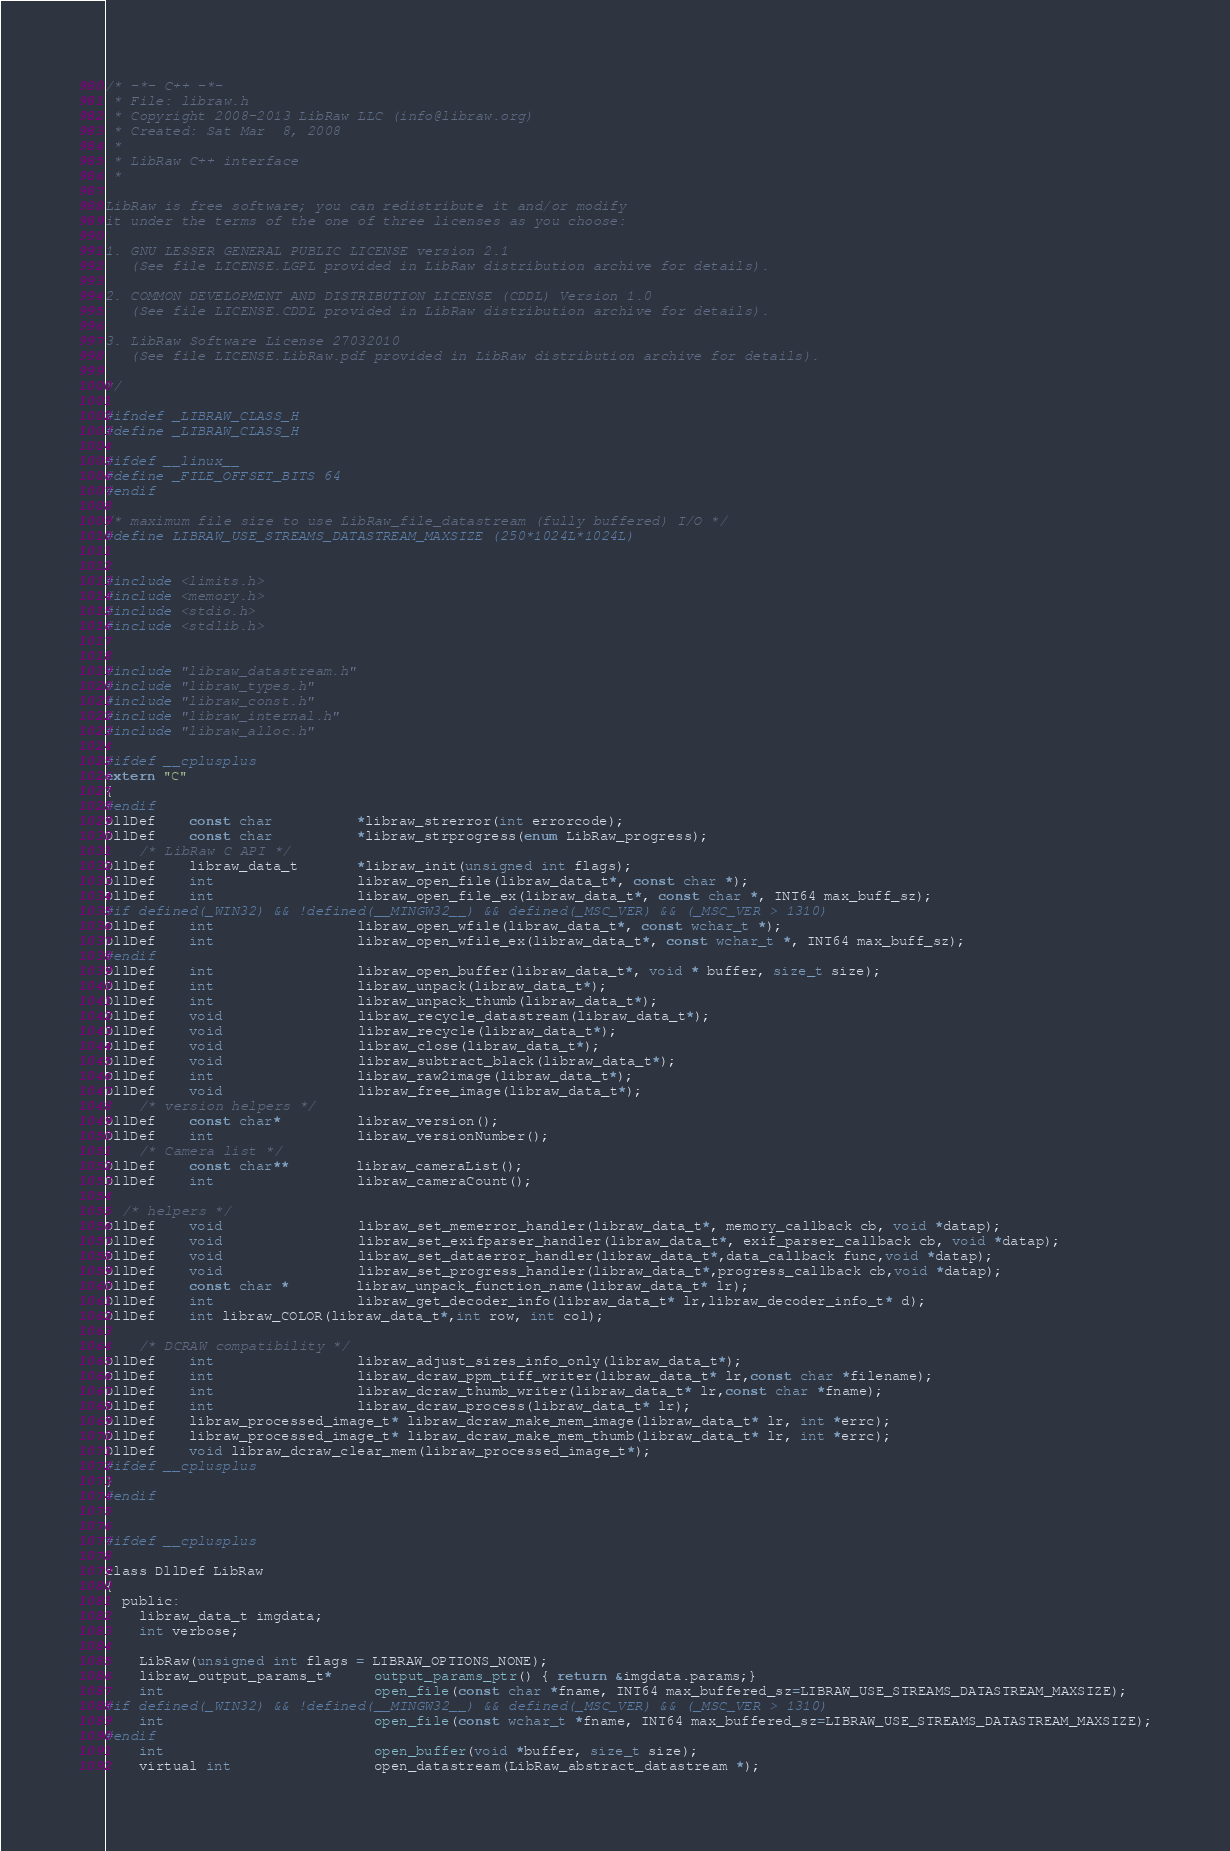Convert code to text. <code><loc_0><loc_0><loc_500><loc_500><_C_>/* -*- C++ -*-
 * File: libraw.h
 * Copyright 2008-2013 LibRaw LLC (info@libraw.org)
 * Created: Sat Mar  8, 2008 
 *
 * LibRaw C++ interface
 *

LibRaw is free software; you can redistribute it and/or modify
it under the terms of the one of three licenses as you choose:

1. GNU LESSER GENERAL PUBLIC LICENSE version 2.1
   (See file LICENSE.LGPL provided in LibRaw distribution archive for details).

2. COMMON DEVELOPMENT AND DISTRIBUTION LICENSE (CDDL) Version 1.0
   (See file LICENSE.CDDL provided in LibRaw distribution archive for details).

3. LibRaw Software License 27032010
   (See file LICENSE.LibRaw.pdf provided in LibRaw distribution archive for details).

*/

#ifndef _LIBRAW_CLASS_H
#define _LIBRAW_CLASS_H

#ifdef __linux__
#define _FILE_OFFSET_BITS 64
#endif

/* maximum file size to use LibRaw_file_datastream (fully buffered) I/O */
#define LIBRAW_USE_STREAMS_DATASTREAM_MAXSIZE (250*1024L*1024L)


#include <limits.h>
#include <memory.h>
#include <stdio.h>
#include <stdlib.h>


#include "libraw_datastream.h"
#include "libraw_types.h"
#include "libraw_const.h"
#include "libraw_internal.h"
#include "libraw_alloc.h"

#ifdef __cplusplus
extern "C" 
{
#endif
DllDef    const char          *libraw_strerror(int errorcode);
DllDef    const char          *libraw_strprogress(enum LibRaw_progress);
    /* LibRaw C API */
DllDef    libraw_data_t       *libraw_init(unsigned int flags);
DllDef    int                 libraw_open_file(libraw_data_t*, const char *);
DllDef    int                 libraw_open_file_ex(libraw_data_t*, const char *, INT64 max_buff_sz);
#if defined(_WIN32) && !defined(__MINGW32__) && defined(_MSC_VER) && (_MSC_VER > 1310)
DllDef    int                 libraw_open_wfile(libraw_data_t*, const wchar_t *);
DllDef    int                 libraw_open_wfile_ex(libraw_data_t*, const wchar_t *, INT64 max_buff_sz);
#endif
DllDef    int                 libraw_open_buffer(libraw_data_t*, void * buffer, size_t size);
DllDef    int                 libraw_unpack(libraw_data_t*);
DllDef    int                 libraw_unpack_thumb(libraw_data_t*);
DllDef    void                libraw_recycle_datastream(libraw_data_t*);
DllDef    void                libraw_recycle(libraw_data_t*);
DllDef    void                libraw_close(libraw_data_t*);
DllDef    void                libraw_subtract_black(libraw_data_t*);
DllDef    int                 libraw_raw2image(libraw_data_t*);
DllDef    void                libraw_free_image(libraw_data_t*);
    /* version helpers */
DllDef    const char*         libraw_version();
DllDef    int                 libraw_versionNumber();
    /* Camera list */
DllDef    const char**        libraw_cameraList();
DllDef    int                 libraw_cameraCount();

  /* helpers */
DllDef    void                libraw_set_memerror_handler(libraw_data_t*, memory_callback cb, void *datap);
DllDef    void                libraw_set_exifparser_handler(libraw_data_t*, exif_parser_callback cb, void *datap);
DllDef    void                libraw_set_dataerror_handler(libraw_data_t*,data_callback func,void *datap);
DllDef    void                libraw_set_progress_handler(libraw_data_t*,progress_callback cb,void *datap);
DllDef    const char *        libraw_unpack_function_name(libraw_data_t* lr);
DllDef    int                 libraw_get_decoder_info(libraw_data_t* lr,libraw_decoder_info_t* d);
DllDef    int libraw_COLOR(libraw_data_t*,int row, int col);

    /* DCRAW compatibility */
DllDef    int                 libraw_adjust_sizes_info_only(libraw_data_t*);
DllDef    int                 libraw_dcraw_ppm_tiff_writer(libraw_data_t* lr,const char *filename);
DllDef    int                 libraw_dcraw_thumb_writer(libraw_data_t* lr,const char *fname);
DllDef    int                 libraw_dcraw_process(libraw_data_t* lr);
DllDef    libraw_processed_image_t* libraw_dcraw_make_mem_image(libraw_data_t* lr, int *errc);
DllDef    libraw_processed_image_t* libraw_dcraw_make_mem_thumb(libraw_data_t* lr, int *errc);
DllDef    void libraw_dcraw_clear_mem(libraw_processed_image_t*);
#ifdef __cplusplus
}
#endif


#ifdef __cplusplus

class DllDef LibRaw
{
  public:
    libraw_data_t imgdata;
    int verbose;

    LibRaw(unsigned int flags = LIBRAW_OPTIONS_NONE);
    libraw_output_params_t*     output_params_ptr() { return &imgdata.params;}
    int                         open_file(const char *fname, INT64 max_buffered_sz=LIBRAW_USE_STREAMS_DATASTREAM_MAXSIZE);
#if defined(_WIN32) && !defined(__MINGW32__) && defined(_MSC_VER) && (_MSC_VER > 1310)
	int                         open_file(const wchar_t *fname, INT64 max_buffered_sz=LIBRAW_USE_STREAMS_DATASTREAM_MAXSIZE);
#endif
    int                         open_buffer(void *buffer, size_t size);
    virtual int                 open_datastream(LibRaw_abstract_datastream *);</code> 